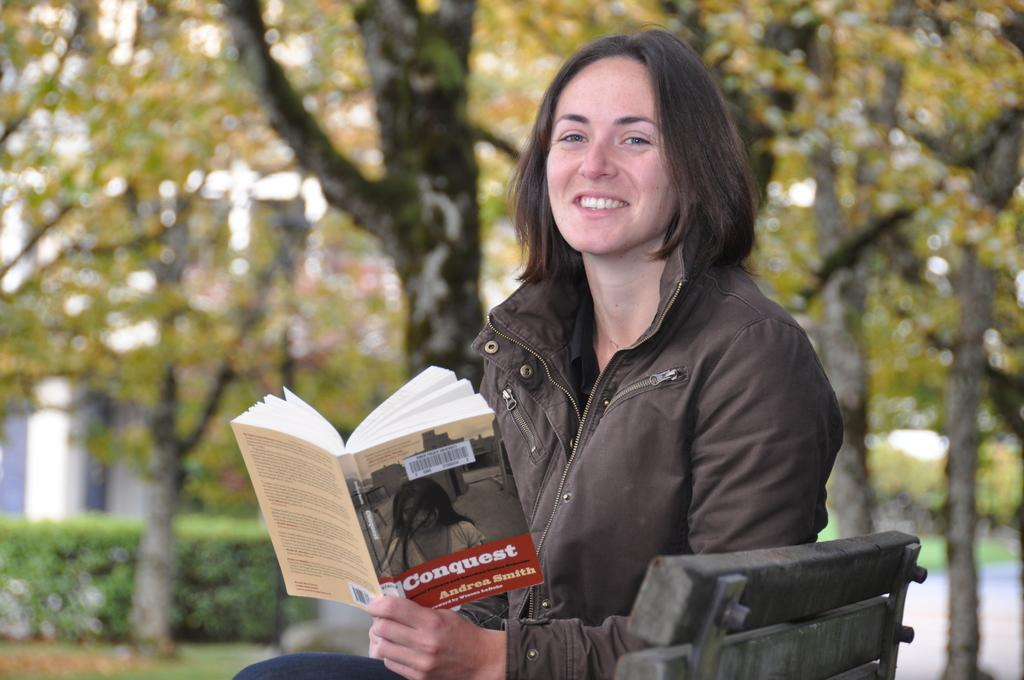<image>
Render a clear and concise summary of the photo. A woman sitting on a park bench with a book in her hand that reads Conquest by Andrea Smith. 